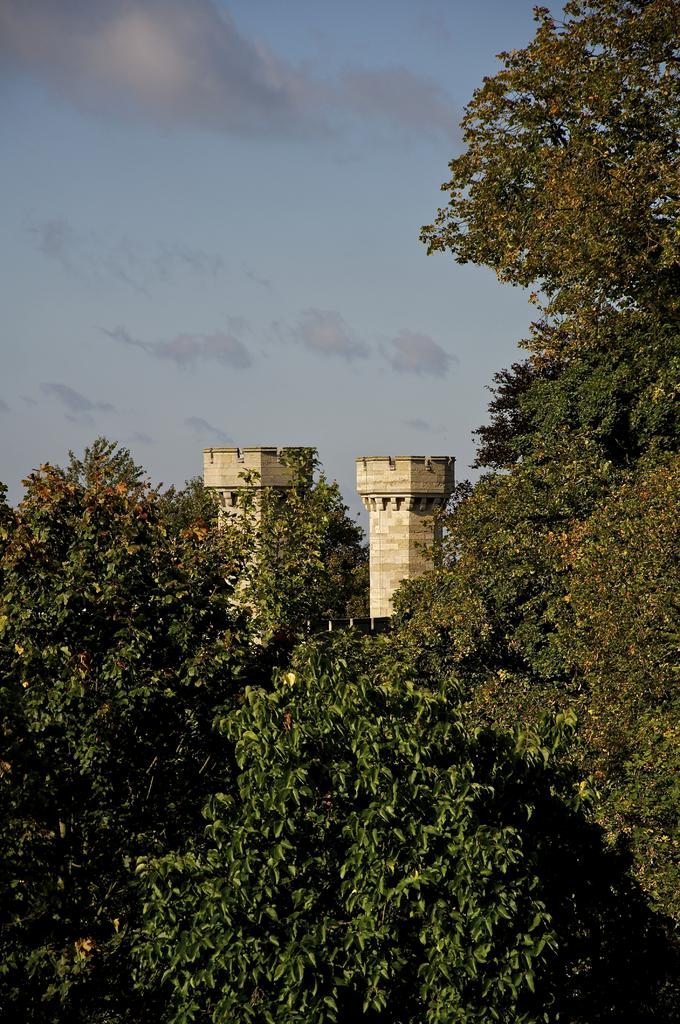What can be seen in the foreground area of the image? There are trees and towers in the foreground area of the image. What is visible in the background of the image? The sky is visible in the background of the image. What type of government is depicted in the image? There is no depiction of a government in the image; it features trees, towers, and the sky. What type of rice can be seen growing in the foreground area of the image? There is no rice present in the image; it features trees and towers in the foreground area. 